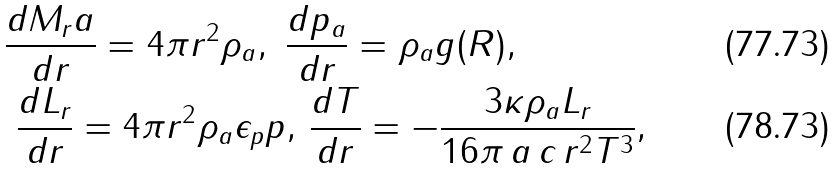Convert formula to latex. <formula><loc_0><loc_0><loc_500><loc_500>& \frac { d M _ { r } a } { d r } = 4 \pi r ^ { 2 } \rho _ { a } , \ \frac { d p _ { a } } { d r } = \rho _ { a } g ( R ) , \\ & \ \frac { d L _ { r } } { d r } = 4 \pi r ^ { 2 } \rho _ { a } \epsilon _ { p } p , \, \frac { d T } { d r } = - \frac { 3 \kappa \rho _ { a } L _ { r } } { 1 6 \pi \, a \, c \, r ^ { 2 } T ^ { 3 } } ,</formula> 